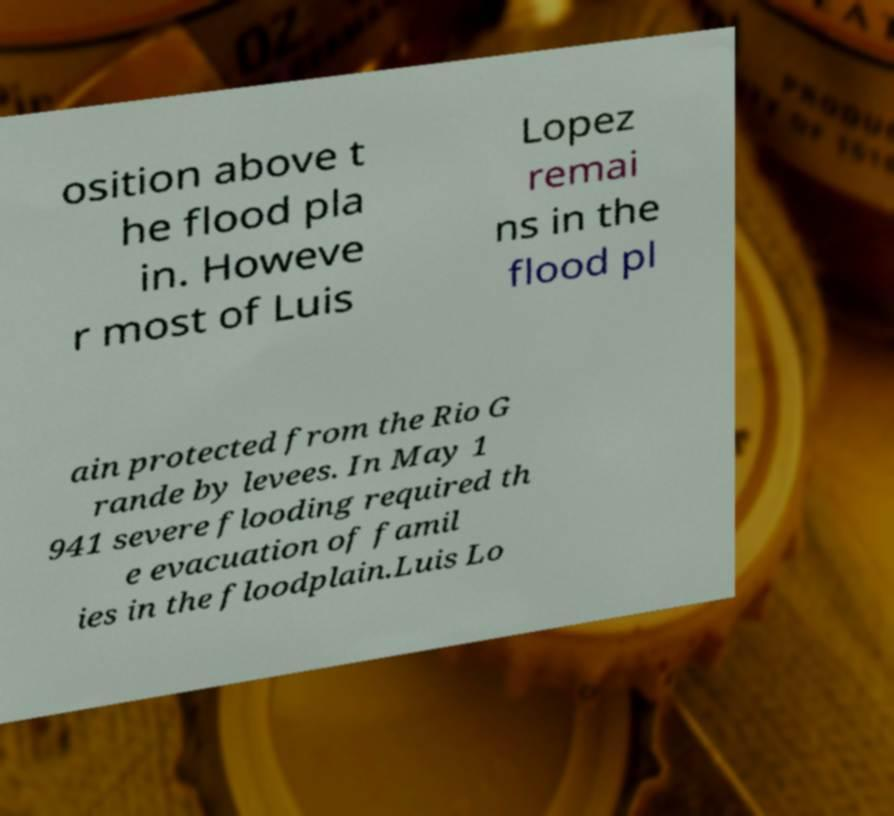What messages or text are displayed in this image? I need them in a readable, typed format. osition above t he flood pla in. Howeve r most of Luis Lopez remai ns in the flood pl ain protected from the Rio G rande by levees. In May 1 941 severe flooding required th e evacuation of famil ies in the floodplain.Luis Lo 